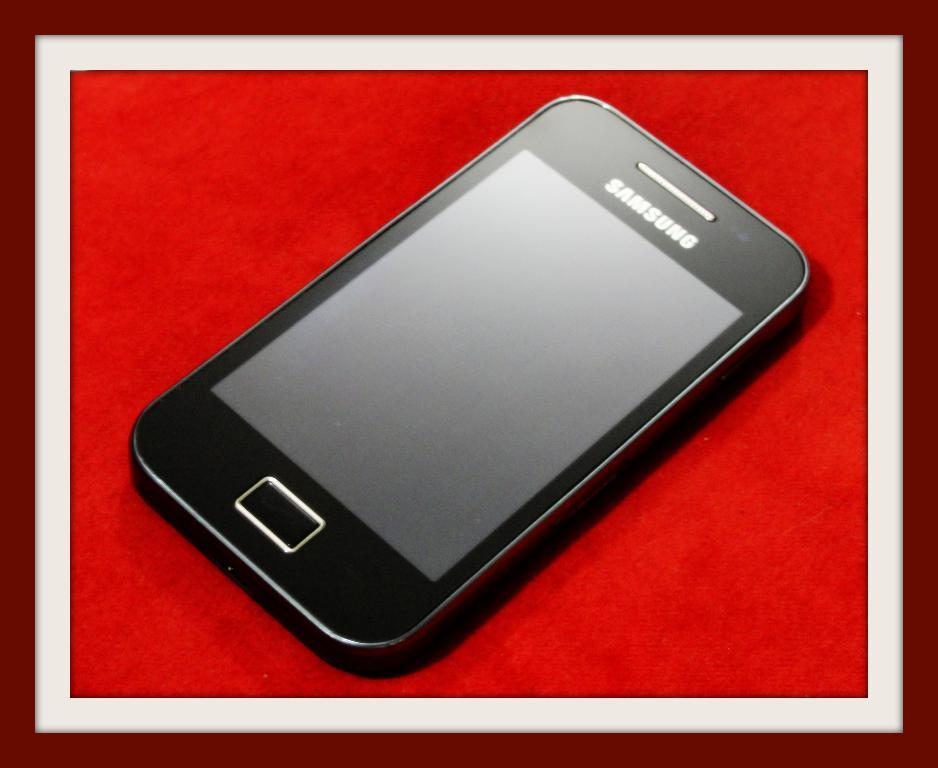<image>
Summarize the visual content of the image. a Samsung cell phone framed on a red background 